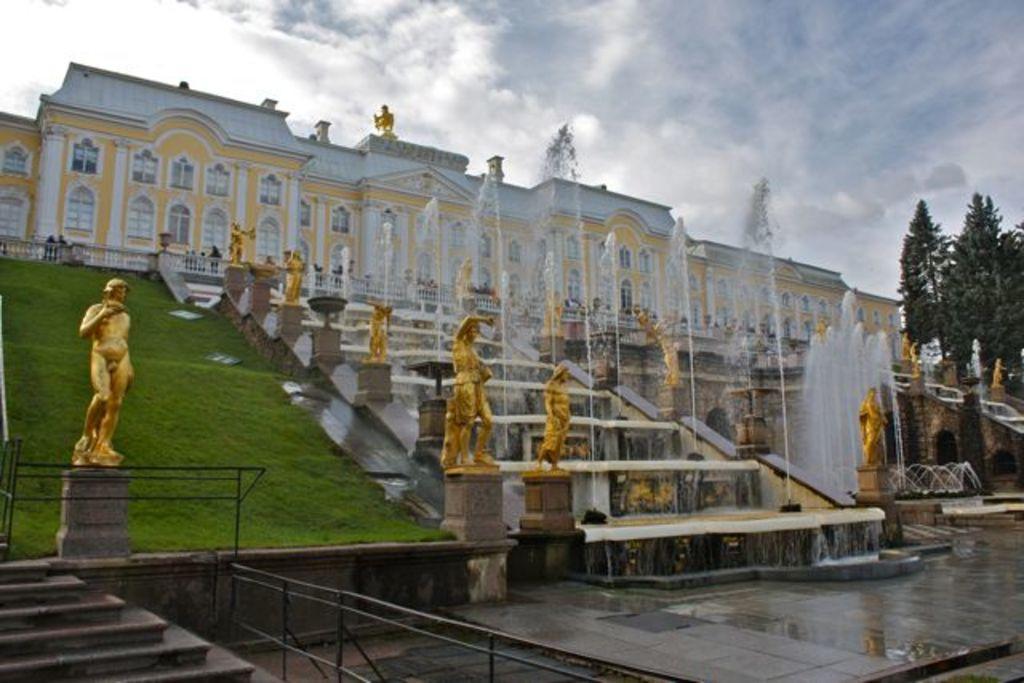Please provide a concise description of this image. Here we can see sculptures, trees, and water. This is grass. In the background we can see a building and sky with clouds. 